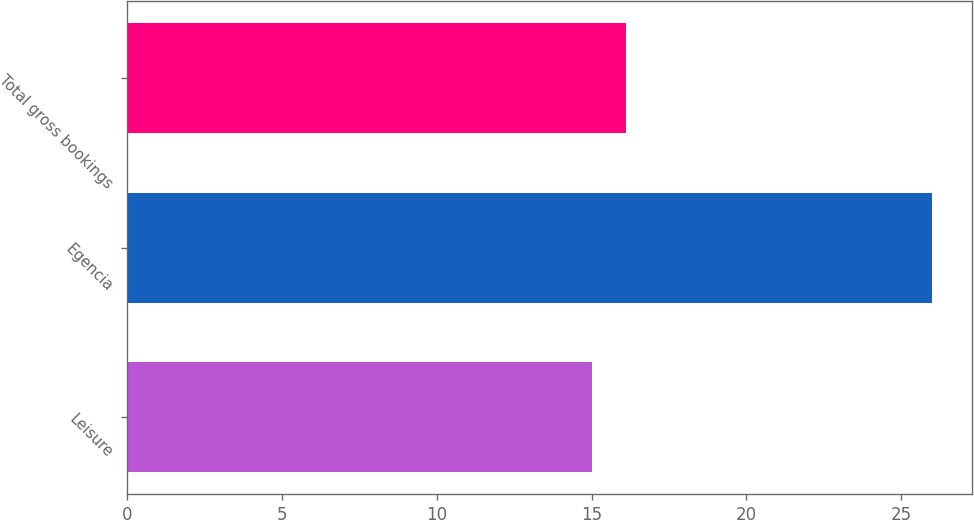<chart> <loc_0><loc_0><loc_500><loc_500><bar_chart><fcel>Leisure<fcel>Egencia<fcel>Total gross bookings<nl><fcel>15<fcel>26<fcel>16.1<nl></chart> 